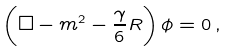<formula> <loc_0><loc_0><loc_500><loc_500>\left ( \square - m ^ { 2 } - \frac { \gamma } { 6 } R \right ) \phi = 0 \, ,</formula> 